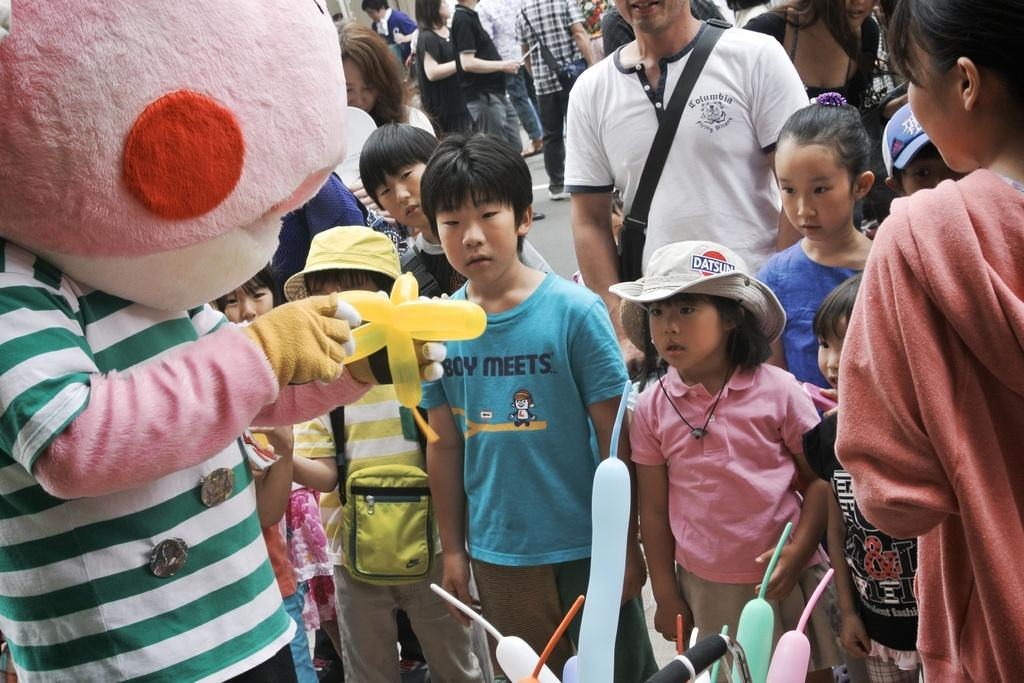How many individuals are present in the image? There are many kids in the image, along with other people. What are the people in the image doing? They are watching a person in a cartoon costume who is holding a toy. What is the person in the costume wearing? The person in the costume is wearing a cartoon costume. What is the person in the costume holding? The person in the costume is holding a toy. What type of office furniture can be seen in the image? There is no office furniture present in the image; it features many kids and people watching a person in a cartoon costume holding a toy. 